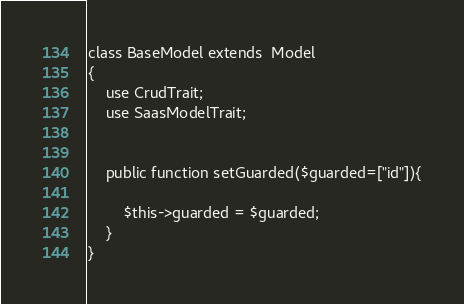Convert code to text. <code><loc_0><loc_0><loc_500><loc_500><_PHP_>class BaseModel extends  Model
{
    use CrudTrait;
    use SaasModelTrait;


    public function setGuarded($guarded=["id"]){

        $this->guarded = $guarded;
    }
}
</code> 